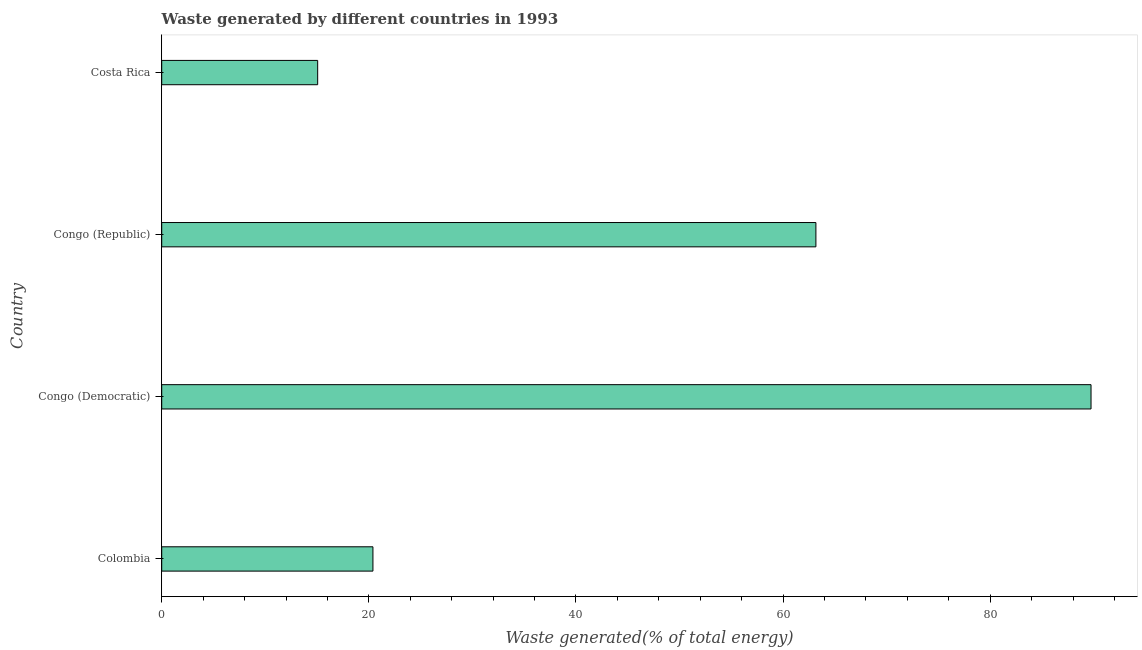Does the graph contain grids?
Give a very brief answer. No. What is the title of the graph?
Provide a short and direct response. Waste generated by different countries in 1993. What is the label or title of the X-axis?
Provide a succinct answer. Waste generated(% of total energy). What is the amount of waste generated in Congo (Democratic)?
Make the answer very short. 89.73. Across all countries, what is the maximum amount of waste generated?
Your response must be concise. 89.73. Across all countries, what is the minimum amount of waste generated?
Your answer should be compact. 15.06. In which country was the amount of waste generated maximum?
Provide a succinct answer. Congo (Democratic). In which country was the amount of waste generated minimum?
Give a very brief answer. Costa Rica. What is the sum of the amount of waste generated?
Offer a terse response. 188.35. What is the difference between the amount of waste generated in Colombia and Congo (Democratic)?
Make the answer very short. -69.33. What is the average amount of waste generated per country?
Offer a terse response. 47.09. What is the median amount of waste generated?
Provide a short and direct response. 41.78. What is the ratio of the amount of waste generated in Congo (Republic) to that in Costa Rica?
Your answer should be very brief. 4.2. Is the amount of waste generated in Congo (Democratic) less than that in Congo (Republic)?
Your answer should be very brief. No. What is the difference between the highest and the second highest amount of waste generated?
Make the answer very short. 26.56. Is the sum of the amount of waste generated in Congo (Republic) and Costa Rica greater than the maximum amount of waste generated across all countries?
Keep it short and to the point. No. What is the difference between the highest and the lowest amount of waste generated?
Your answer should be compact. 74.67. In how many countries, is the amount of waste generated greater than the average amount of waste generated taken over all countries?
Provide a short and direct response. 2. What is the difference between two consecutive major ticks on the X-axis?
Offer a very short reply. 20. Are the values on the major ticks of X-axis written in scientific E-notation?
Offer a very short reply. No. What is the Waste generated(% of total energy) of Colombia?
Make the answer very short. 20.4. What is the Waste generated(% of total energy) in Congo (Democratic)?
Your response must be concise. 89.73. What is the Waste generated(% of total energy) in Congo (Republic)?
Provide a short and direct response. 63.16. What is the Waste generated(% of total energy) of Costa Rica?
Ensure brevity in your answer.  15.06. What is the difference between the Waste generated(% of total energy) in Colombia and Congo (Democratic)?
Ensure brevity in your answer.  -69.33. What is the difference between the Waste generated(% of total energy) in Colombia and Congo (Republic)?
Offer a terse response. -42.77. What is the difference between the Waste generated(% of total energy) in Colombia and Costa Rica?
Your answer should be very brief. 5.34. What is the difference between the Waste generated(% of total energy) in Congo (Democratic) and Congo (Republic)?
Your response must be concise. 26.56. What is the difference between the Waste generated(% of total energy) in Congo (Democratic) and Costa Rica?
Keep it short and to the point. 74.67. What is the difference between the Waste generated(% of total energy) in Congo (Republic) and Costa Rica?
Your answer should be very brief. 48.11. What is the ratio of the Waste generated(% of total energy) in Colombia to that in Congo (Democratic)?
Provide a short and direct response. 0.23. What is the ratio of the Waste generated(% of total energy) in Colombia to that in Congo (Republic)?
Provide a succinct answer. 0.32. What is the ratio of the Waste generated(% of total energy) in Colombia to that in Costa Rica?
Provide a succinct answer. 1.35. What is the ratio of the Waste generated(% of total energy) in Congo (Democratic) to that in Congo (Republic)?
Provide a short and direct response. 1.42. What is the ratio of the Waste generated(% of total energy) in Congo (Democratic) to that in Costa Rica?
Ensure brevity in your answer.  5.96. What is the ratio of the Waste generated(% of total energy) in Congo (Republic) to that in Costa Rica?
Your response must be concise. 4.2. 